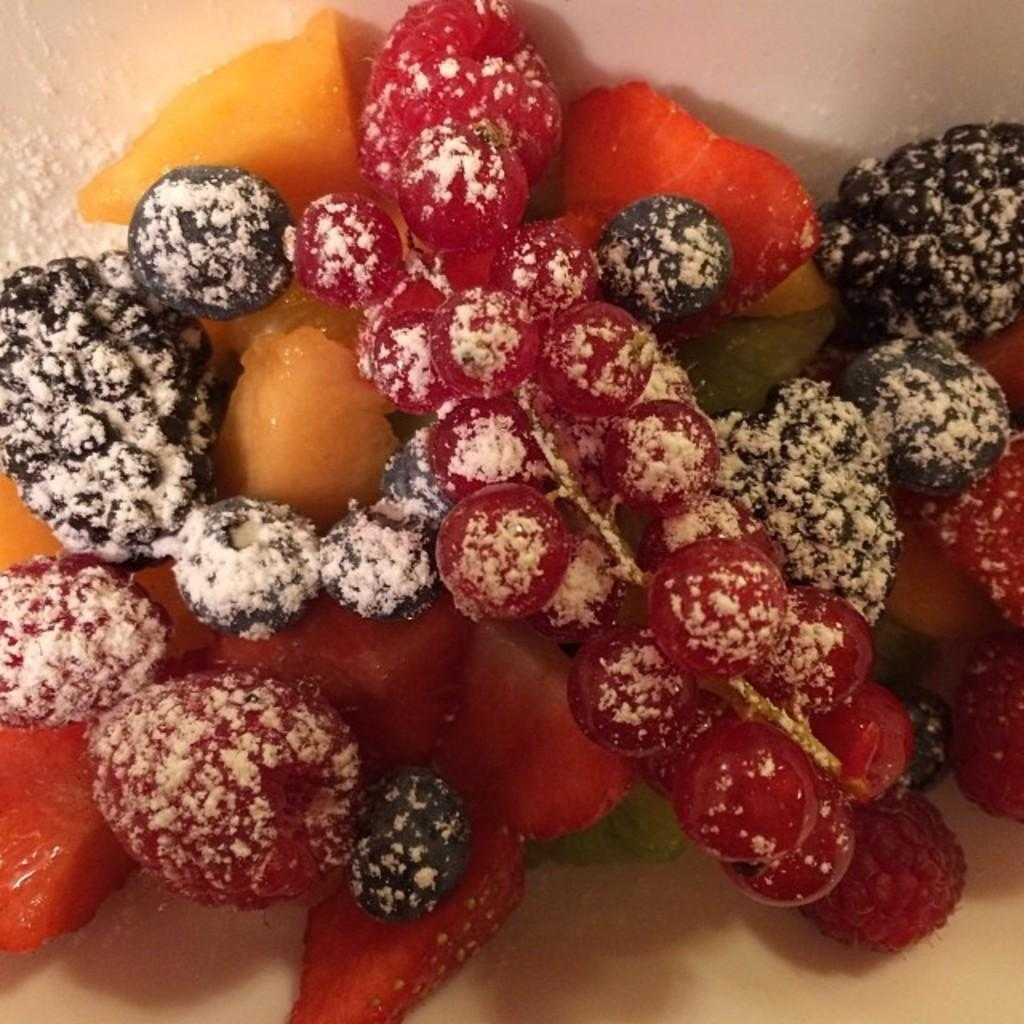What type of food can be seen in the image? There are fruits in the image. How are the fruits arranged or displayed in the image? The fruits are in a plate. What type of gardening tool is used to serve the fruits in the image? There is: There is no gardening tool present in the image; the fruits are in a plate. What type of magic trick is being performed with the fruits in the image? There is no magic trick being performed in the image; it simply shows fruits in a plate. 